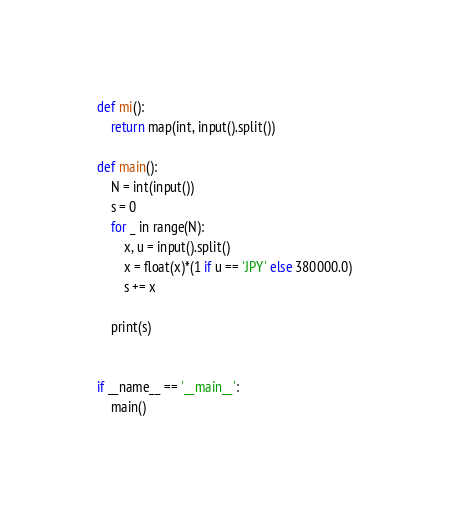<code> <loc_0><loc_0><loc_500><loc_500><_Python_>def mi():
    return map(int, input().split())

def main():
    N = int(input())
    s = 0
    for _ in range(N):
        x, u = input().split()
        x = float(x)*(1 if u == 'JPY' else 380000.0)
        s += x

    print(s)


if __name__ == '__main__':
    main()</code> 